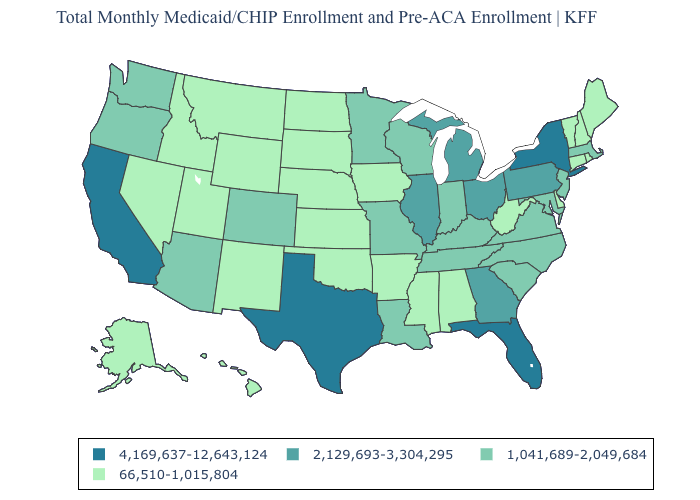Does the map have missing data?
Keep it brief. No. Which states hav the highest value in the West?
Answer briefly. California. What is the lowest value in states that border Kentucky?
Quick response, please. 66,510-1,015,804. What is the highest value in the West ?
Be succinct. 4,169,637-12,643,124. What is the lowest value in the USA?
Keep it brief. 66,510-1,015,804. Which states have the lowest value in the Northeast?
Be succinct. Connecticut, Maine, New Hampshire, Rhode Island, Vermont. Name the states that have a value in the range 1,041,689-2,049,684?
Give a very brief answer. Arizona, Colorado, Indiana, Kentucky, Louisiana, Maryland, Massachusetts, Minnesota, Missouri, New Jersey, North Carolina, Oregon, South Carolina, Tennessee, Virginia, Washington, Wisconsin. Name the states that have a value in the range 2,129,693-3,304,295?
Write a very short answer. Georgia, Illinois, Michigan, Ohio, Pennsylvania. Name the states that have a value in the range 2,129,693-3,304,295?
Concise answer only. Georgia, Illinois, Michigan, Ohio, Pennsylvania. Does Rhode Island have a lower value than North Carolina?
Keep it brief. Yes. Which states have the lowest value in the Northeast?
Write a very short answer. Connecticut, Maine, New Hampshire, Rhode Island, Vermont. Name the states that have a value in the range 1,041,689-2,049,684?
Give a very brief answer. Arizona, Colorado, Indiana, Kentucky, Louisiana, Maryland, Massachusetts, Minnesota, Missouri, New Jersey, North Carolina, Oregon, South Carolina, Tennessee, Virginia, Washington, Wisconsin. What is the highest value in states that border Indiana?
Quick response, please. 2,129,693-3,304,295. 